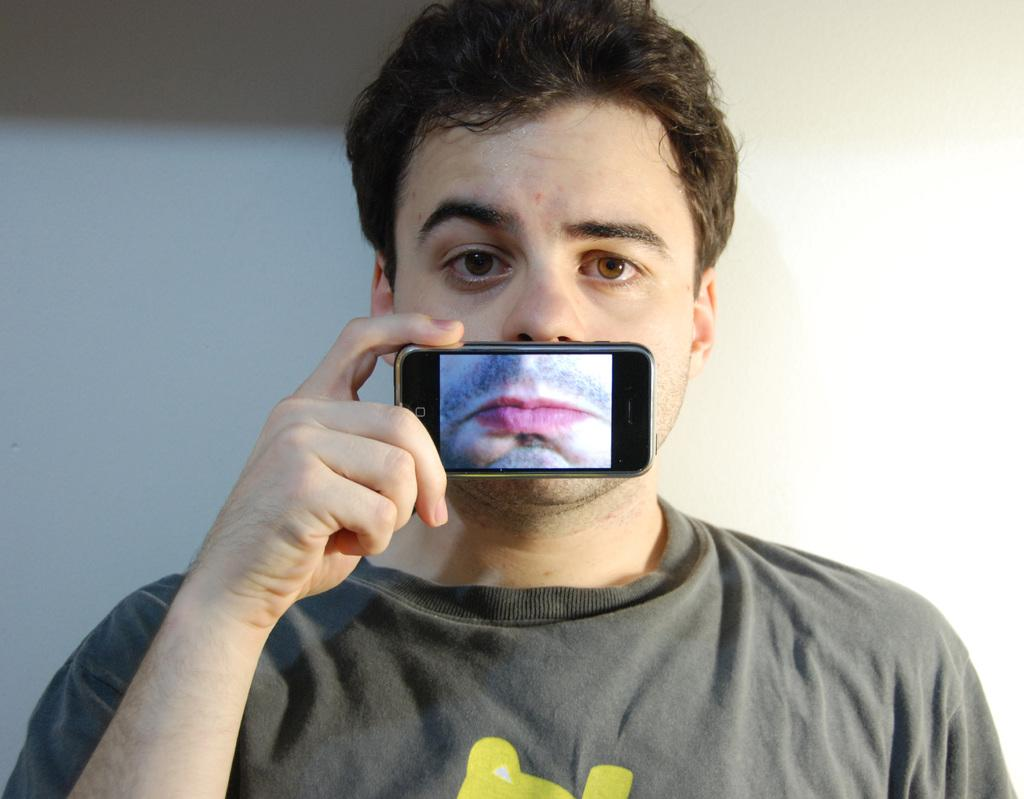Who is present in the image? There is a man in the image. What is the man holding in his hand? The man is holding a mobile in his hand. What is the man using the mobile for? The man is using the mobile to capture his mouth. What type of ice can be seen melting on the machine in the image? There is no ice or machine present in the image. 